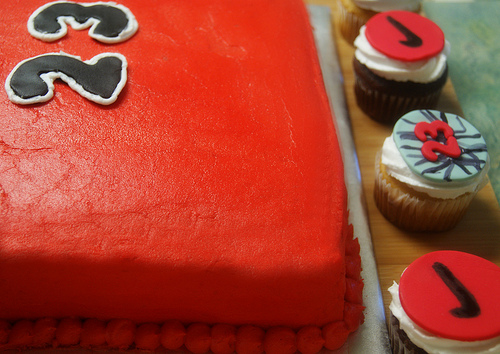<image>
Is there a cupcake on the cupcake? No. The cupcake is not positioned on the cupcake. They may be near each other, but the cupcake is not supported by or resting on top of the cupcake. 